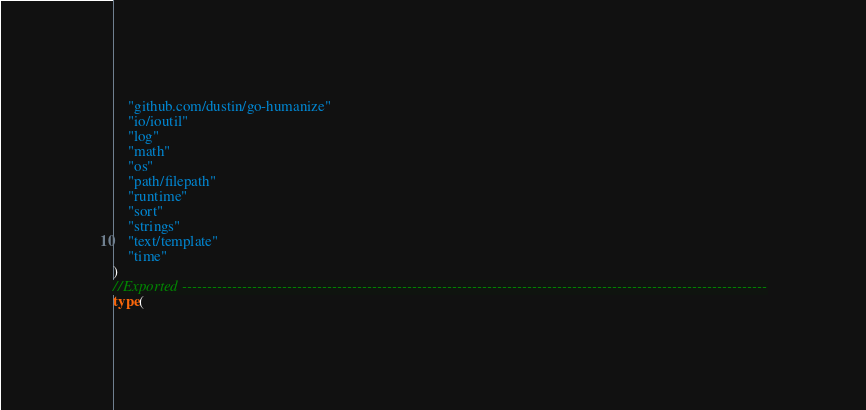<code> <loc_0><loc_0><loc_500><loc_500><_Go_>    "github.com/dustin/go-humanize"
    "io/ioutil"
    "log"
    "math"
    "os"
    "path/filepath"
    "runtime"
    "sort"
    "strings"
    "text/template"
    "time"
)
//Exported ---------------------------------------------------------------------------------------------------------------------
type(</code> 